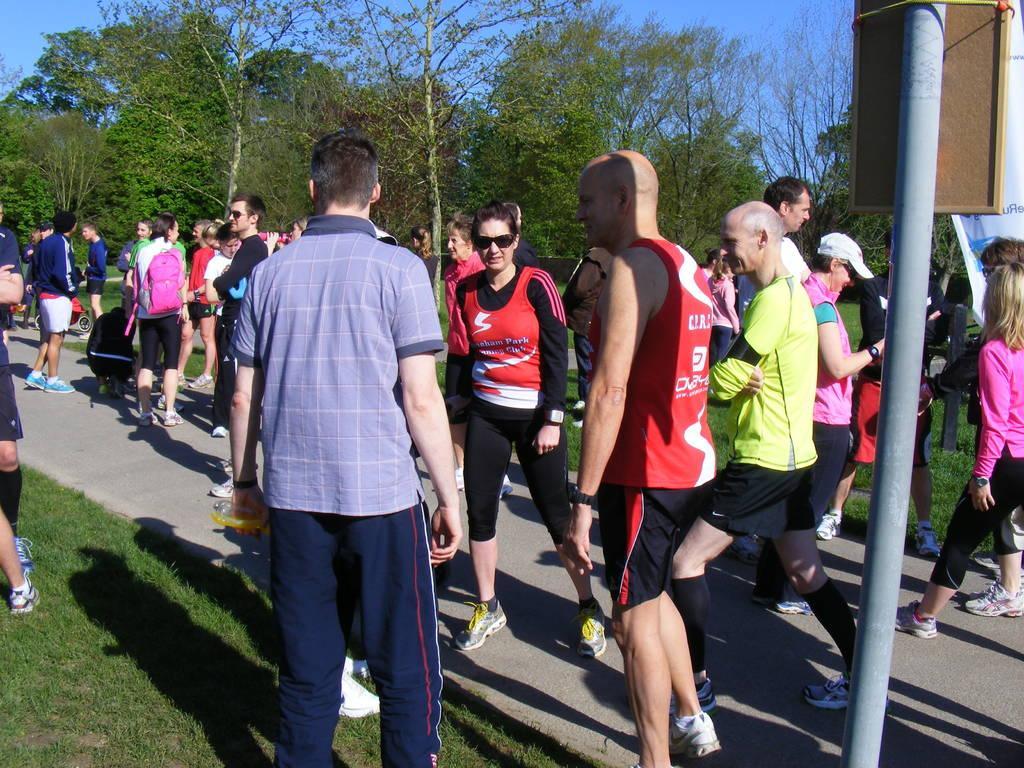Could you give a brief overview of what you see in this image? In this image, on the left there is a man, he wears a t shirt, trouser, he is holding a bottle. On the right there are people, pole, board, poster. In the background there are many people, trees, road, sky. In the middle there is a woman, she wears a t shirt, trouser, shoes. 